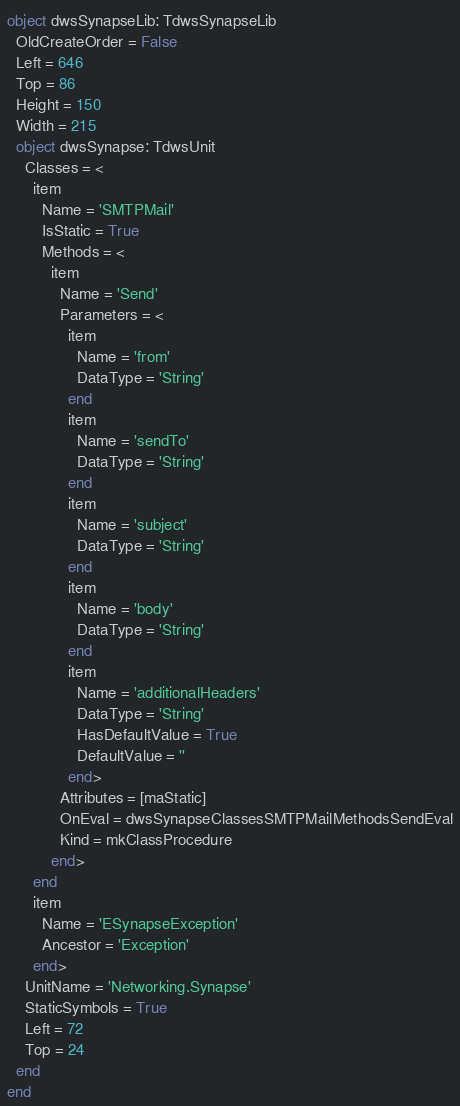Convert code to text. <code><loc_0><loc_0><loc_500><loc_500><_Pascal_>object dwsSynapseLib: TdwsSynapseLib
  OldCreateOrder = False
  Left = 646
  Top = 86
  Height = 150
  Width = 215
  object dwsSynapse: TdwsUnit
    Classes = <
      item
        Name = 'SMTPMail'
        IsStatic = True
        Methods = <
          item
            Name = 'Send'
            Parameters = <
              item
                Name = 'from'
                DataType = 'String'
              end
              item
                Name = 'sendTo'
                DataType = 'String'
              end
              item
                Name = 'subject'
                DataType = 'String'
              end
              item
                Name = 'body'
                DataType = 'String'
              end
              item
                Name = 'additionalHeaders'
                DataType = 'String'
                HasDefaultValue = True
                DefaultValue = ''
              end>
            Attributes = [maStatic]
            OnEval = dwsSynapseClassesSMTPMailMethodsSendEval
            Kind = mkClassProcedure
          end>
      end
      item
        Name = 'ESynapseException'
        Ancestor = 'Exception'
      end>
    UnitName = 'Networking.Synapse'
    StaticSymbols = True
    Left = 72
    Top = 24
  end
end
</code> 